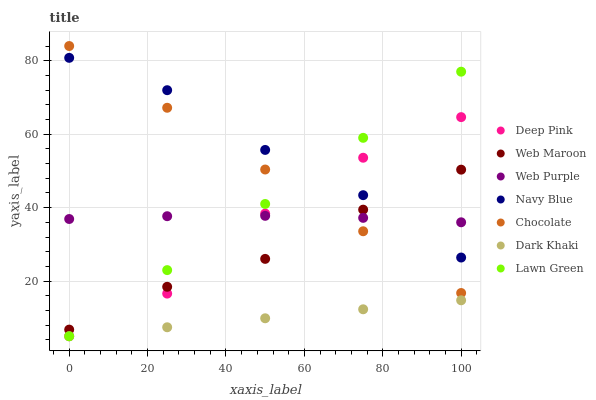Does Dark Khaki have the minimum area under the curve?
Answer yes or no. Yes. Does Navy Blue have the maximum area under the curve?
Answer yes or no. Yes. Does Deep Pink have the minimum area under the curve?
Answer yes or no. No. Does Deep Pink have the maximum area under the curve?
Answer yes or no. No. Is Dark Khaki the smoothest?
Answer yes or no. Yes. Is Deep Pink the roughest?
Answer yes or no. Yes. Is Navy Blue the smoothest?
Answer yes or no. No. Is Navy Blue the roughest?
Answer yes or no. No. Does Lawn Green have the lowest value?
Answer yes or no. Yes. Does Navy Blue have the lowest value?
Answer yes or no. No. Does Chocolate have the highest value?
Answer yes or no. Yes. Does Deep Pink have the highest value?
Answer yes or no. No. Is Dark Khaki less than Web Purple?
Answer yes or no. Yes. Is Chocolate greater than Dark Khaki?
Answer yes or no. Yes. Does Web Maroon intersect Lawn Green?
Answer yes or no. Yes. Is Web Maroon less than Lawn Green?
Answer yes or no. No. Is Web Maroon greater than Lawn Green?
Answer yes or no. No. Does Dark Khaki intersect Web Purple?
Answer yes or no. No. 